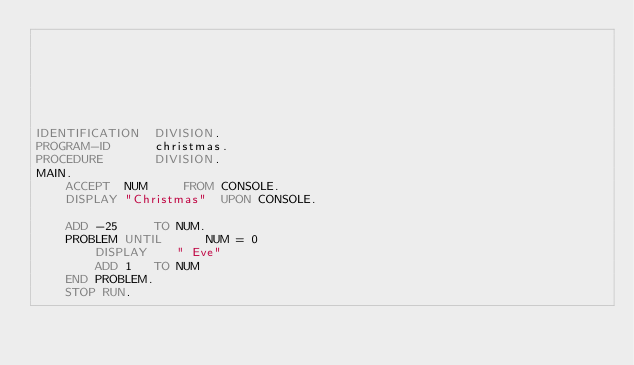<code> <loc_0><loc_0><loc_500><loc_500><_COBOL_>






IDENTIFICATION  DIVISION.
PROGRAM-ID      christmas.
PROCEDURE       DIVISION.
MAIN.
    ACCEPT  NUM     FROM CONSOLE.
    DISPLAY "Christmas"  UPON CONSOLE.

    ADD -25     TO NUM.
    PROBLEM UNTIL      NUM = 0
        DISPLAY    " Eve"
        ADD 1   TO NUM
    END PROBLEM.
    STOP RUN.
</code> 